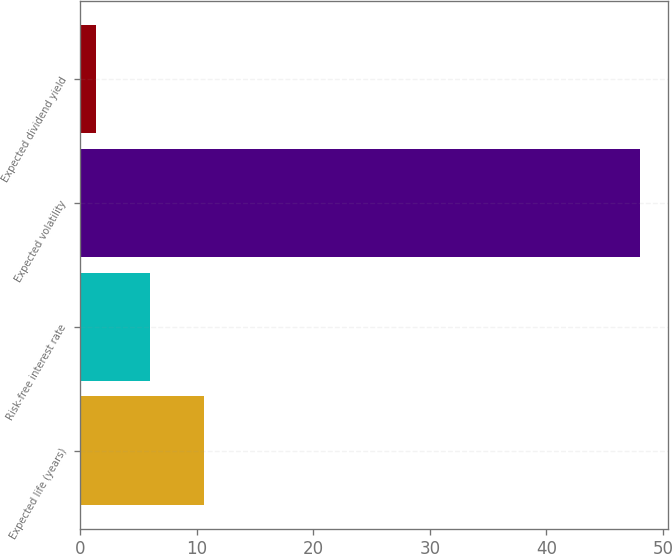Convert chart. <chart><loc_0><loc_0><loc_500><loc_500><bar_chart><fcel>Expected life (years)<fcel>Risk-free interest rate<fcel>Expected volatility<fcel>Expected dividend yield<nl><fcel>10.64<fcel>5.97<fcel>48<fcel>1.3<nl></chart> 